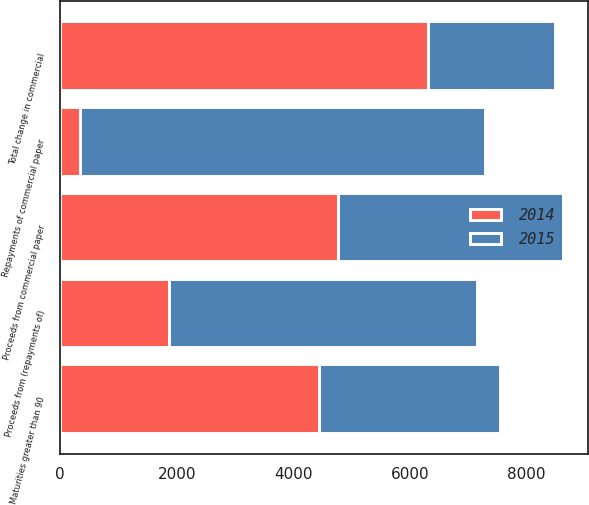Convert chart. <chart><loc_0><loc_0><loc_500><loc_500><stacked_bar_chart><ecel><fcel>Proceeds from (repayments of)<fcel>Proceeds from commercial paper<fcel>Repayments of commercial paper<fcel>Maturities greater than 90<fcel>Total change in commercial<nl><fcel>2015<fcel>5293<fcel>3851<fcel>6953<fcel>3102<fcel>2191<nl><fcel>2014<fcel>1865<fcel>4771<fcel>330<fcel>4441<fcel>6306<nl></chart> 